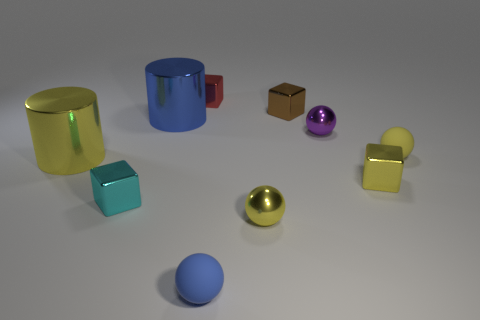What number of other tiny blocks are made of the same material as the brown block?
Offer a terse response. 3. What shape is the yellow object that is to the left of the tiny yellow rubber sphere and behind the tiny yellow metal block?
Your answer should be compact. Cylinder. Does the tiny yellow ball that is behind the cyan object have the same material as the tiny blue sphere?
Keep it short and to the point. Yes. There is another metal ball that is the same size as the purple metallic ball; what is its color?
Offer a terse response. Yellow. There is a blue cylinder that is made of the same material as the yellow cylinder; what size is it?
Offer a terse response. Large. What number of other objects are there of the same size as the purple ball?
Provide a short and direct response. 7. There is a tiny yellow thing to the left of the purple metal object; what material is it?
Your answer should be compact. Metal. The tiny brown thing that is to the right of the small yellow ball on the left side of the tiny matte ball that is right of the small brown shiny thing is what shape?
Provide a succinct answer. Cube. Is the size of the purple metal object the same as the blue matte sphere?
Ensure brevity in your answer.  Yes. What number of objects are either yellow rubber things or tiny metal cubes that are on the left side of the big blue thing?
Give a very brief answer. 2. 